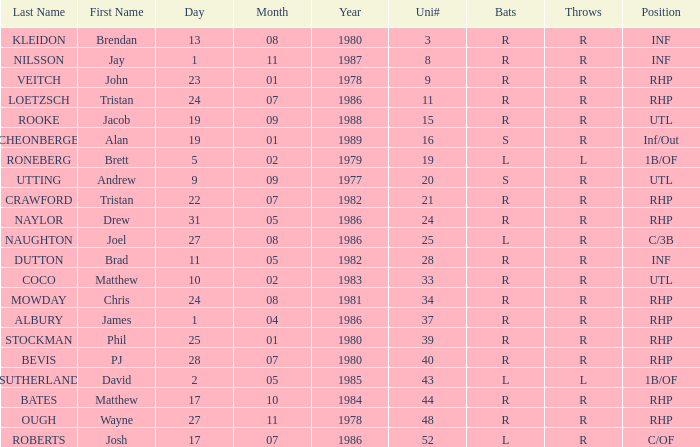Which Surname has Throws of l, and a DOB of 5/02/79? RONEBERG. 